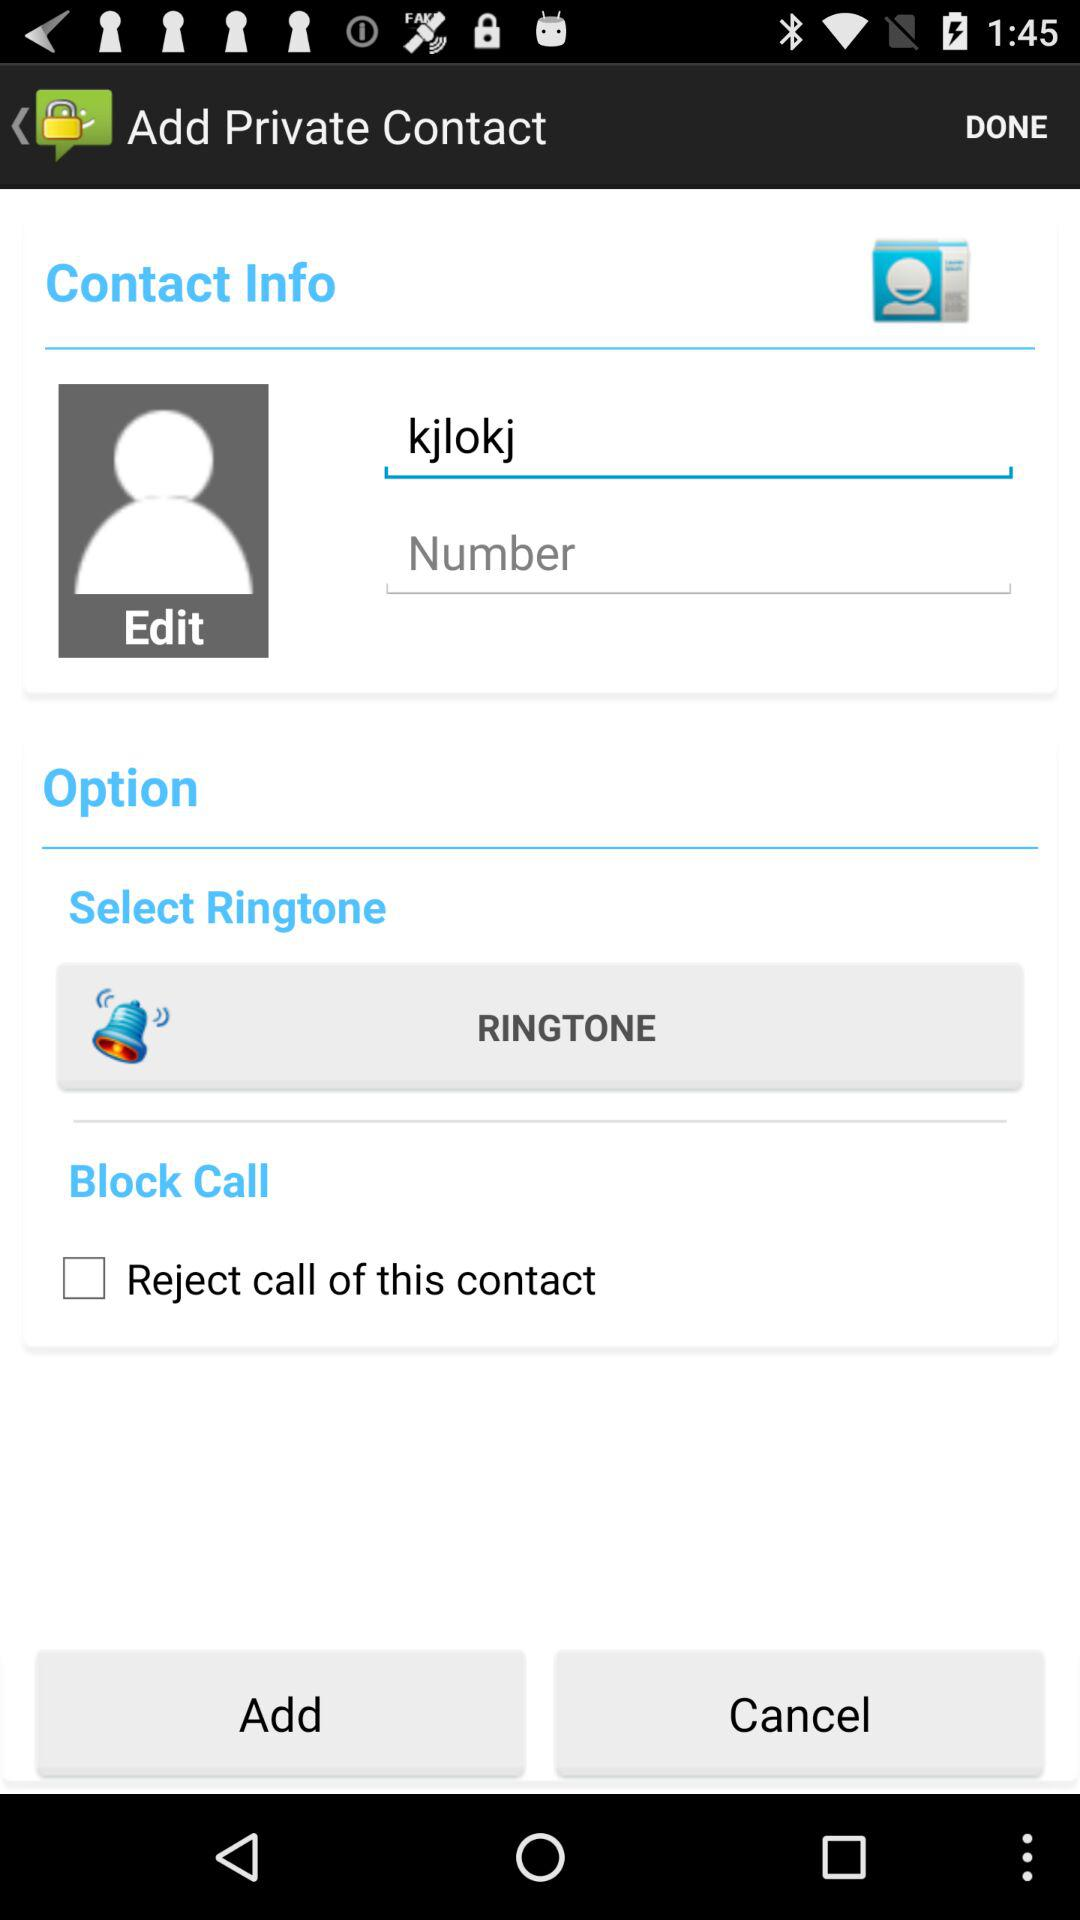What's the name? The name is "kjlokj". 